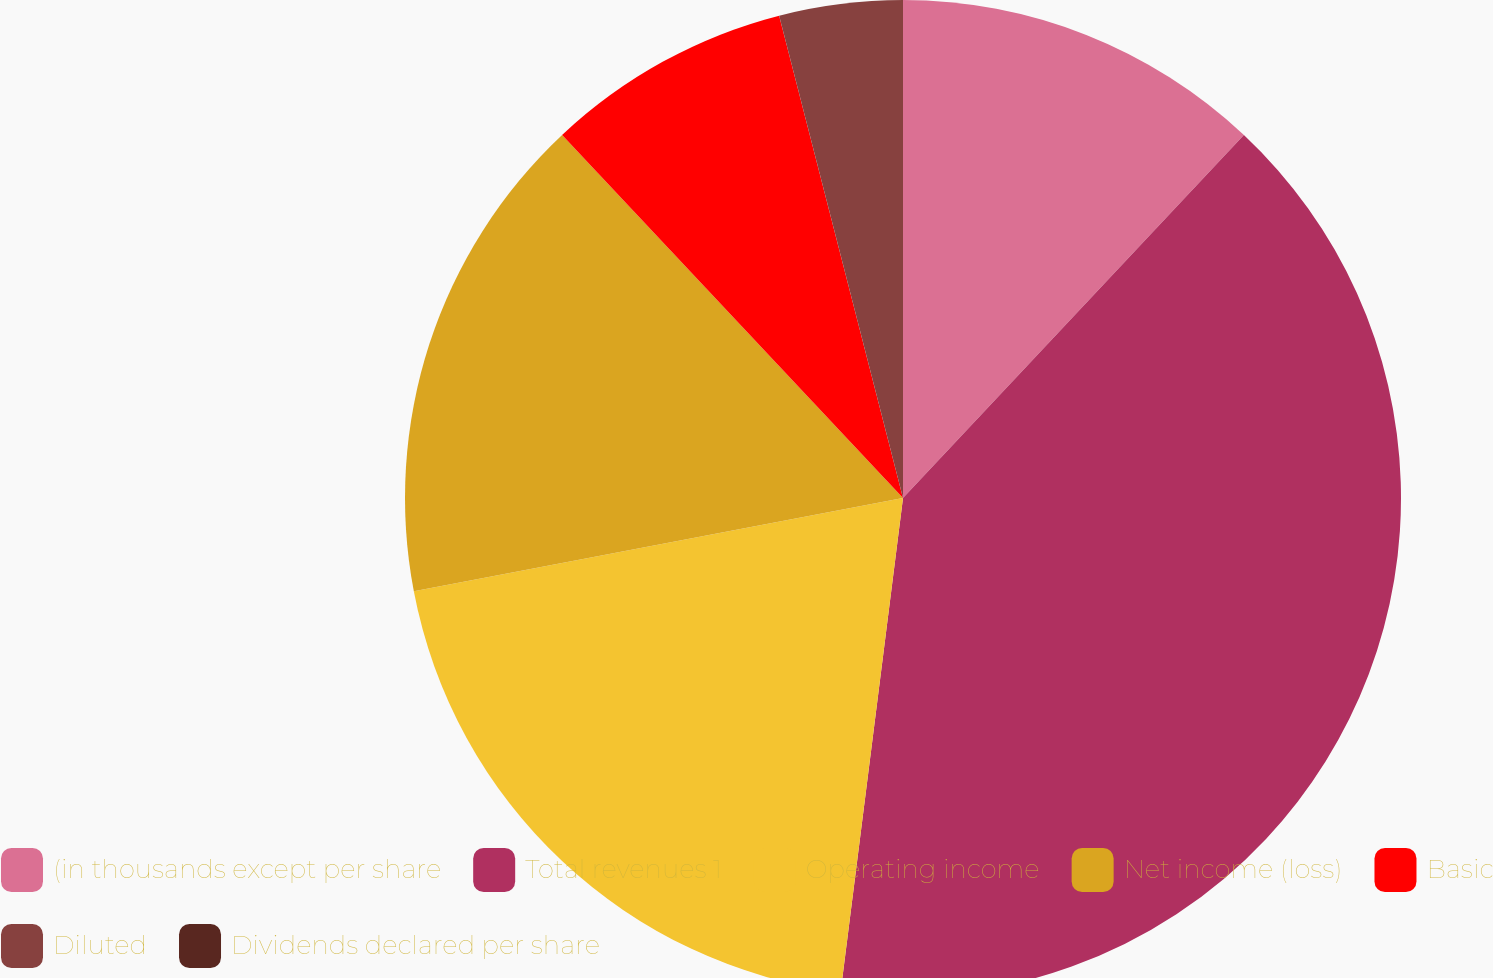Convert chart. <chart><loc_0><loc_0><loc_500><loc_500><pie_chart><fcel>(in thousands except per share<fcel>Total revenues 1<fcel>Operating income<fcel>Net income (loss)<fcel>Basic<fcel>Diluted<fcel>Dividends declared per share<nl><fcel>12.0%<fcel>40.0%<fcel>20.0%<fcel>16.0%<fcel>8.0%<fcel>4.0%<fcel>0.0%<nl></chart> 